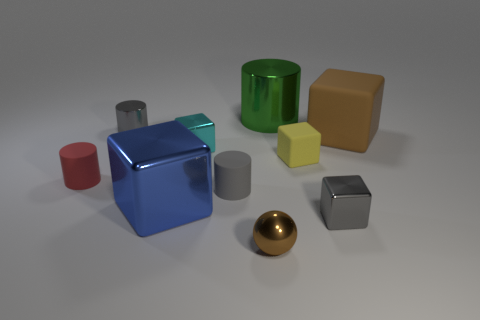Subtract all big metallic cylinders. How many cylinders are left? 3 Subtract all gray spheres. How many gray cylinders are left? 2 Subtract all cylinders. How many objects are left? 6 Subtract 3 cylinders. How many cylinders are left? 1 Subtract all red cylinders. How many cylinders are left? 3 Subtract 0 purple spheres. How many objects are left? 10 Subtract all red cubes. Subtract all brown cylinders. How many cubes are left? 5 Subtract all tiny blue shiny objects. Subtract all small metallic spheres. How many objects are left? 9 Add 8 rubber blocks. How many rubber blocks are left? 10 Add 9 small metallic spheres. How many small metallic spheres exist? 10 